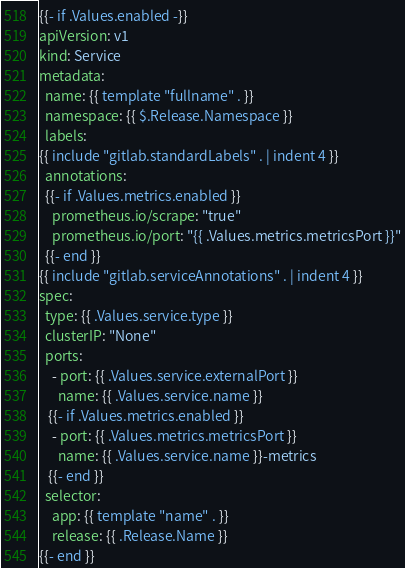Convert code to text. <code><loc_0><loc_0><loc_500><loc_500><_YAML_>{{- if .Values.enabled -}}
apiVersion: v1
kind: Service
metadata:
  name: {{ template "fullname" . }}
  namespace: {{ $.Release.Namespace }}
  labels:
{{ include "gitlab.standardLabels" . | indent 4 }}
  annotations:
  {{- if .Values.metrics.enabled }}
    prometheus.io/scrape: "true"
    prometheus.io/port: "{{ .Values.metrics.metricsPort }}"
  {{- end }}
{{ include "gitlab.serviceAnnotations" . | indent 4 }}
spec:
  type: {{ .Values.service.type }}
  clusterIP: "None"
  ports:
    - port: {{ .Values.service.externalPort }}
      name: {{ .Values.service.name }}
   {{- if .Values.metrics.enabled }}
    - port: {{ .Values.metrics.metricsPort }}
      name: {{ .Values.service.name }}-metrics
   {{- end }}
  selector:
    app: {{ template "name" . }}
    release: {{ .Release.Name }}
{{- end }}
</code> 